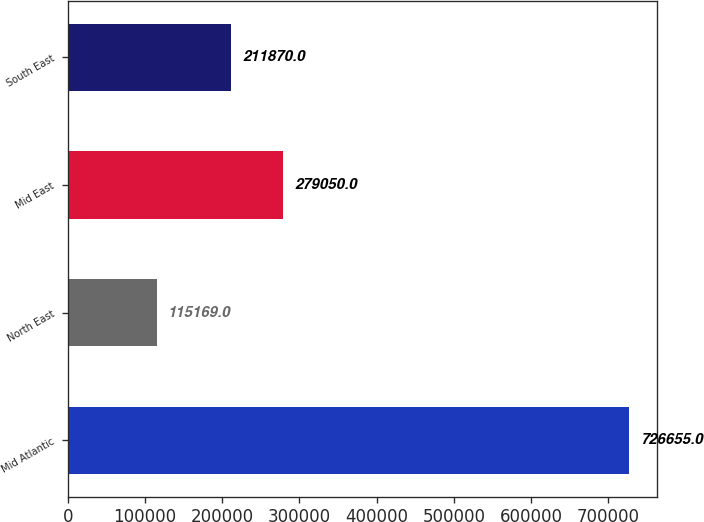<chart> <loc_0><loc_0><loc_500><loc_500><bar_chart><fcel>Mid Atlantic<fcel>North East<fcel>Mid East<fcel>South East<nl><fcel>726655<fcel>115169<fcel>279050<fcel>211870<nl></chart> 